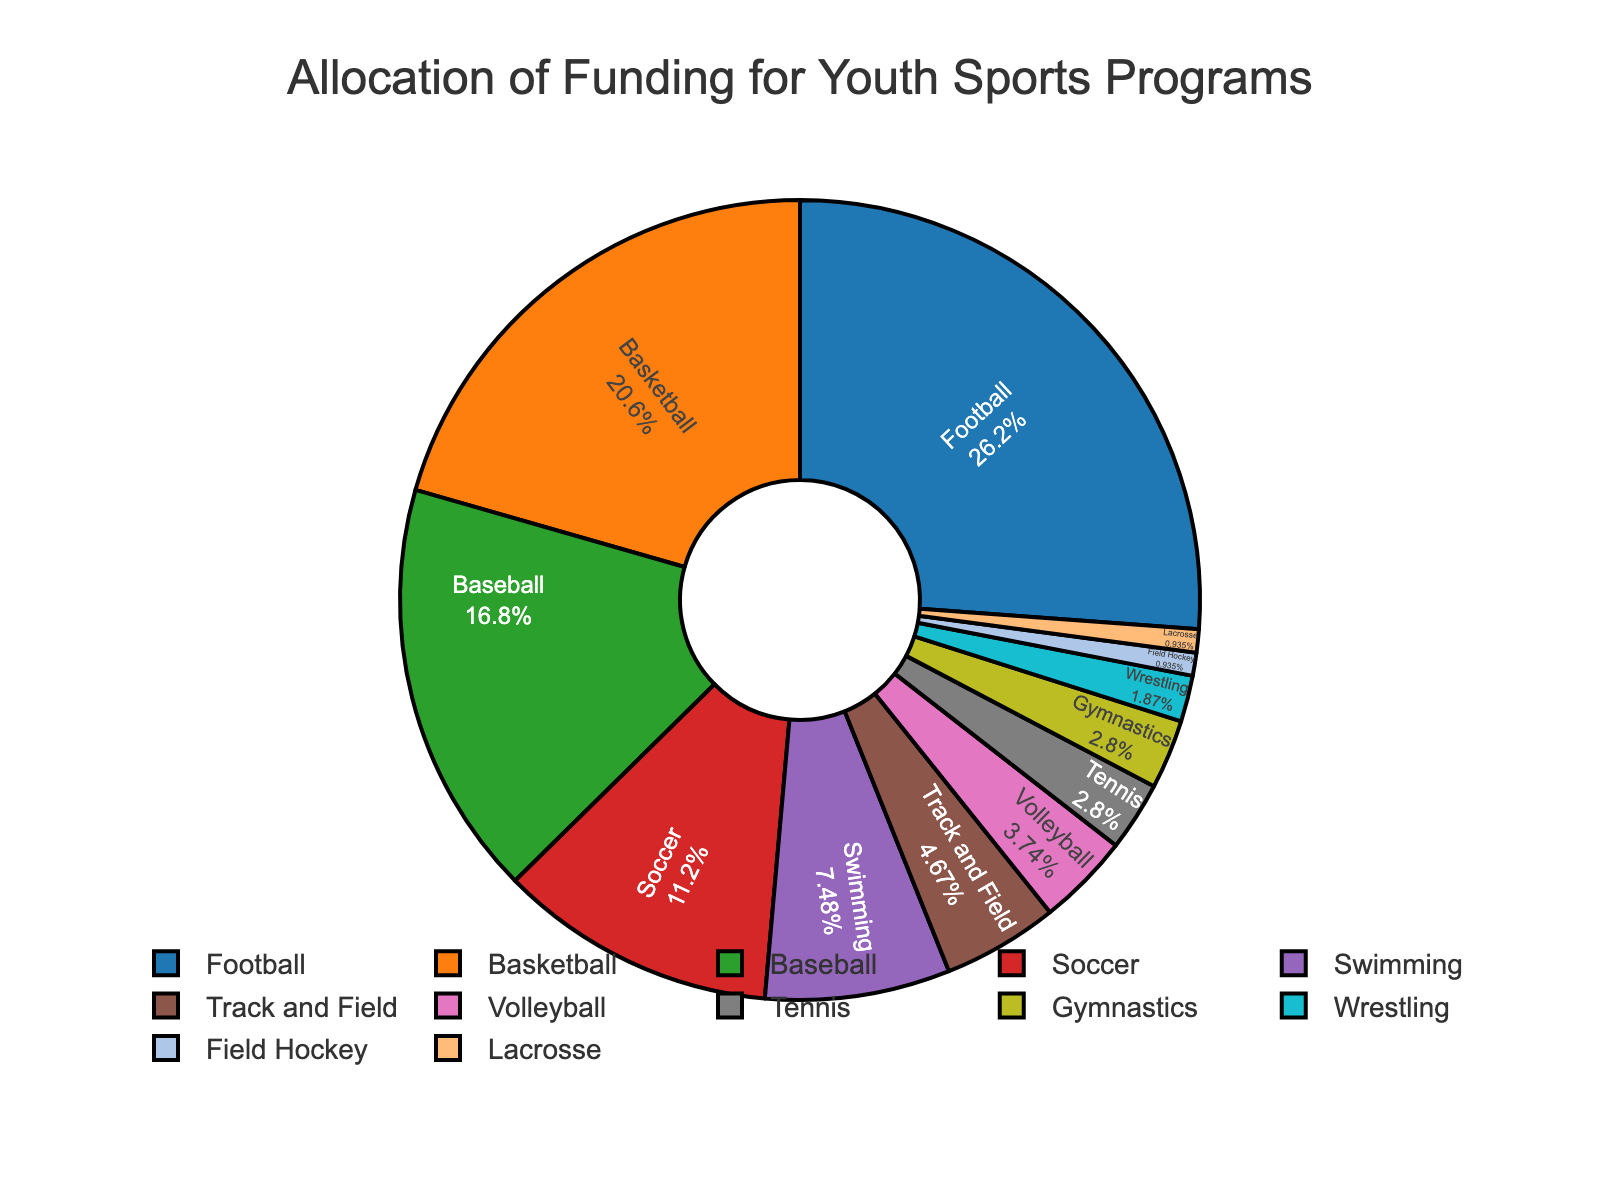What is the sum of the funding percentages allocated to Soccer, Swimming, and Track and Field? To find the sum of the funding percentages for Soccer, Swimming, and Track and Field, we add up their respective percentages: 12% (Soccer), 8% (Swimming), and 5% (Track and Field). The calculation is 12 + 8 + 5 = 25.
Answer: 25% Which sport receives the most funding? The sport with the highest funding percentage can be identified by the largest segment in the pie chart. According to the data, Football receives the most funding with 28%.
Answer: Football How does the funding for Basketball compare to Baseball? Basketball receives 22% of the funding, while Baseball receives 18%. By comparing these percentages, we see that Basketball receives more funding than Baseball.
Answer: Basketball receives more Which sport has the smallest allocation, and what percentage of the total funding does it receive? The smallest segment in the pie chart represents the sport with the least funding. According to the data, both Field Hockey and Lacrosse have the smallest allocation, each receiving 1% of the total funding.
Answer: Field Hockey and Lacrosse; 1% What is the difference in funding percentage between Football and Soccer? Football is allocated 28% of the funding, whereas Soccer is allocated 12%. To find the difference, we subtract the smaller percentage from the larger one: 28 - 12 = 16.
Answer: 16% What are the combined funding percentages for sports with less than 5% allocation? Sports with less than 5% allocation are Volleyball (4%), Tennis (3%), Gymnastics (3%), Wrestling (2%), Field Hockey (1%), and Lacrosse (1%). Summing their percentages: 4 + 3 + 3 + 2 + 1 + 1 = 14.
Answer: 14% Which color represents Swimming on the pie chart? By examining the legend provided in the pie chart, we can identify the color associated with Swimming. According to the color mapping, Swimming is represented by a specific segment's color.
Answer: [purple, based on data and color list] How much more funding does Basketball receive compared to Volleyball? Basketball receives 22% of the funding, while Volleyball receives 4%. The difference between the two percentages is calculated as 22 - 4 = 18.
Answer: 18% Which sports receive an equal percentage of funding, and what is that percentage? The pie chart shows that Tennis and Gymnastics each receive equal funding, both being allocated 3% of the total funding.
Answer: Tennis and Gymnastics; 3% What percentage of the total funding is allocated to Football and Basketball combined? The funding percentage for Football is 28% and for Basketball is 22%. The combined total is found by adding these two percentages: 28 + 22 = 50.
Answer: 50% 